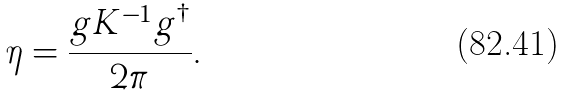<formula> <loc_0><loc_0><loc_500><loc_500>\eta = \frac { g K ^ { - 1 } g ^ { \dagger } } { 2 \pi } .</formula> 